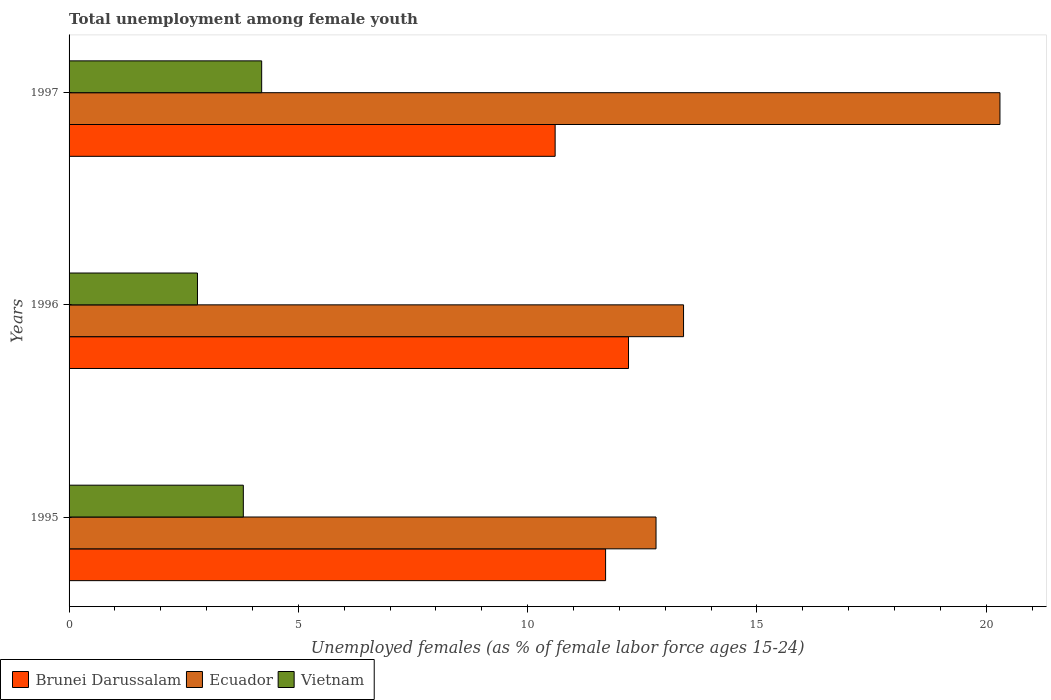How many groups of bars are there?
Your response must be concise. 3. How many bars are there on the 3rd tick from the bottom?
Provide a short and direct response. 3. What is the percentage of unemployed females in in Brunei Darussalam in 1995?
Your answer should be very brief. 11.7. Across all years, what is the maximum percentage of unemployed females in in Vietnam?
Offer a terse response. 4.2. Across all years, what is the minimum percentage of unemployed females in in Brunei Darussalam?
Your answer should be compact. 10.6. In which year was the percentage of unemployed females in in Vietnam maximum?
Offer a very short reply. 1997. In which year was the percentage of unemployed females in in Ecuador minimum?
Provide a short and direct response. 1995. What is the total percentage of unemployed females in in Vietnam in the graph?
Provide a succinct answer. 10.8. What is the difference between the percentage of unemployed females in in Vietnam in 1995 and that in 1997?
Your answer should be compact. -0.4. What is the difference between the percentage of unemployed females in in Brunei Darussalam in 1997 and the percentage of unemployed females in in Ecuador in 1995?
Offer a very short reply. -2.2. What is the average percentage of unemployed females in in Brunei Darussalam per year?
Your answer should be compact. 11.5. In the year 1995, what is the difference between the percentage of unemployed females in in Ecuador and percentage of unemployed females in in Brunei Darussalam?
Make the answer very short. 1.1. In how many years, is the percentage of unemployed females in in Brunei Darussalam greater than 11 %?
Your answer should be compact. 2. What is the ratio of the percentage of unemployed females in in Vietnam in 1995 to that in 1997?
Give a very brief answer. 0.9. Is the percentage of unemployed females in in Vietnam in 1995 less than that in 1996?
Your answer should be very brief. No. What is the difference between the highest and the second highest percentage of unemployed females in in Brunei Darussalam?
Provide a succinct answer. 0.5. What is the difference between the highest and the lowest percentage of unemployed females in in Brunei Darussalam?
Your answer should be very brief. 1.6. In how many years, is the percentage of unemployed females in in Brunei Darussalam greater than the average percentage of unemployed females in in Brunei Darussalam taken over all years?
Your answer should be compact. 2. Is the sum of the percentage of unemployed females in in Brunei Darussalam in 1995 and 1996 greater than the maximum percentage of unemployed females in in Ecuador across all years?
Make the answer very short. Yes. What does the 3rd bar from the top in 1996 represents?
Ensure brevity in your answer.  Brunei Darussalam. What does the 2nd bar from the bottom in 1996 represents?
Provide a short and direct response. Ecuador. How many bars are there?
Your response must be concise. 9. How many years are there in the graph?
Your answer should be very brief. 3. What is the title of the graph?
Your response must be concise. Total unemployment among female youth. Does "Mali" appear as one of the legend labels in the graph?
Your answer should be very brief. No. What is the label or title of the X-axis?
Offer a very short reply. Unemployed females (as % of female labor force ages 15-24). What is the label or title of the Y-axis?
Give a very brief answer. Years. What is the Unemployed females (as % of female labor force ages 15-24) of Brunei Darussalam in 1995?
Offer a very short reply. 11.7. What is the Unemployed females (as % of female labor force ages 15-24) of Ecuador in 1995?
Your answer should be very brief. 12.8. What is the Unemployed females (as % of female labor force ages 15-24) in Vietnam in 1995?
Keep it short and to the point. 3.8. What is the Unemployed females (as % of female labor force ages 15-24) of Brunei Darussalam in 1996?
Your answer should be very brief. 12.2. What is the Unemployed females (as % of female labor force ages 15-24) in Ecuador in 1996?
Provide a succinct answer. 13.4. What is the Unemployed females (as % of female labor force ages 15-24) of Vietnam in 1996?
Make the answer very short. 2.8. What is the Unemployed females (as % of female labor force ages 15-24) of Brunei Darussalam in 1997?
Provide a short and direct response. 10.6. What is the Unemployed females (as % of female labor force ages 15-24) of Ecuador in 1997?
Provide a succinct answer. 20.3. What is the Unemployed females (as % of female labor force ages 15-24) in Vietnam in 1997?
Offer a very short reply. 4.2. Across all years, what is the maximum Unemployed females (as % of female labor force ages 15-24) in Brunei Darussalam?
Your answer should be very brief. 12.2. Across all years, what is the maximum Unemployed females (as % of female labor force ages 15-24) in Ecuador?
Your response must be concise. 20.3. Across all years, what is the maximum Unemployed females (as % of female labor force ages 15-24) of Vietnam?
Your answer should be very brief. 4.2. Across all years, what is the minimum Unemployed females (as % of female labor force ages 15-24) in Brunei Darussalam?
Make the answer very short. 10.6. Across all years, what is the minimum Unemployed females (as % of female labor force ages 15-24) in Ecuador?
Provide a succinct answer. 12.8. Across all years, what is the minimum Unemployed females (as % of female labor force ages 15-24) of Vietnam?
Offer a terse response. 2.8. What is the total Unemployed females (as % of female labor force ages 15-24) of Brunei Darussalam in the graph?
Give a very brief answer. 34.5. What is the total Unemployed females (as % of female labor force ages 15-24) of Ecuador in the graph?
Your answer should be very brief. 46.5. What is the difference between the Unemployed females (as % of female labor force ages 15-24) of Brunei Darussalam in 1995 and that in 1996?
Make the answer very short. -0.5. What is the difference between the Unemployed females (as % of female labor force ages 15-24) in Ecuador in 1995 and that in 1996?
Offer a very short reply. -0.6. What is the difference between the Unemployed females (as % of female labor force ages 15-24) of Vietnam in 1995 and that in 1996?
Give a very brief answer. 1. What is the difference between the Unemployed females (as % of female labor force ages 15-24) of Brunei Darussalam in 1995 and that in 1997?
Provide a short and direct response. 1.1. What is the difference between the Unemployed females (as % of female labor force ages 15-24) in Vietnam in 1995 and that in 1997?
Offer a very short reply. -0.4. What is the difference between the Unemployed females (as % of female labor force ages 15-24) of Brunei Darussalam in 1996 and that in 1997?
Provide a succinct answer. 1.6. What is the difference between the Unemployed females (as % of female labor force ages 15-24) of Ecuador in 1996 and that in 1997?
Offer a very short reply. -6.9. What is the difference between the Unemployed females (as % of female labor force ages 15-24) in Brunei Darussalam in 1995 and the Unemployed females (as % of female labor force ages 15-24) in Vietnam in 1996?
Provide a succinct answer. 8.9. What is the difference between the Unemployed females (as % of female labor force ages 15-24) in Ecuador in 1995 and the Unemployed females (as % of female labor force ages 15-24) in Vietnam in 1996?
Give a very brief answer. 10. What is the difference between the Unemployed females (as % of female labor force ages 15-24) of Brunei Darussalam in 1995 and the Unemployed females (as % of female labor force ages 15-24) of Ecuador in 1997?
Your answer should be compact. -8.6. What is the average Unemployed females (as % of female labor force ages 15-24) of Ecuador per year?
Your answer should be very brief. 15.5. What is the average Unemployed females (as % of female labor force ages 15-24) of Vietnam per year?
Provide a succinct answer. 3.6. In the year 1995, what is the difference between the Unemployed females (as % of female labor force ages 15-24) in Ecuador and Unemployed females (as % of female labor force ages 15-24) in Vietnam?
Your answer should be compact. 9. In the year 1996, what is the difference between the Unemployed females (as % of female labor force ages 15-24) of Brunei Darussalam and Unemployed females (as % of female labor force ages 15-24) of Ecuador?
Provide a succinct answer. -1.2. In the year 1996, what is the difference between the Unemployed females (as % of female labor force ages 15-24) of Brunei Darussalam and Unemployed females (as % of female labor force ages 15-24) of Vietnam?
Your answer should be compact. 9.4. In the year 1996, what is the difference between the Unemployed females (as % of female labor force ages 15-24) in Ecuador and Unemployed females (as % of female labor force ages 15-24) in Vietnam?
Make the answer very short. 10.6. In the year 1997, what is the difference between the Unemployed females (as % of female labor force ages 15-24) of Brunei Darussalam and Unemployed females (as % of female labor force ages 15-24) of Ecuador?
Provide a short and direct response. -9.7. In the year 1997, what is the difference between the Unemployed females (as % of female labor force ages 15-24) of Ecuador and Unemployed females (as % of female labor force ages 15-24) of Vietnam?
Your answer should be very brief. 16.1. What is the ratio of the Unemployed females (as % of female labor force ages 15-24) in Ecuador in 1995 to that in 1996?
Offer a very short reply. 0.96. What is the ratio of the Unemployed females (as % of female labor force ages 15-24) of Vietnam in 1995 to that in 1996?
Ensure brevity in your answer.  1.36. What is the ratio of the Unemployed females (as % of female labor force ages 15-24) in Brunei Darussalam in 1995 to that in 1997?
Offer a terse response. 1.1. What is the ratio of the Unemployed females (as % of female labor force ages 15-24) in Ecuador in 1995 to that in 1997?
Keep it short and to the point. 0.63. What is the ratio of the Unemployed females (as % of female labor force ages 15-24) of Vietnam in 1995 to that in 1997?
Keep it short and to the point. 0.9. What is the ratio of the Unemployed females (as % of female labor force ages 15-24) in Brunei Darussalam in 1996 to that in 1997?
Your answer should be very brief. 1.15. What is the ratio of the Unemployed females (as % of female labor force ages 15-24) in Ecuador in 1996 to that in 1997?
Your answer should be compact. 0.66. What is the difference between the highest and the second highest Unemployed females (as % of female labor force ages 15-24) of Ecuador?
Keep it short and to the point. 6.9. What is the difference between the highest and the second highest Unemployed females (as % of female labor force ages 15-24) in Vietnam?
Offer a very short reply. 0.4. What is the difference between the highest and the lowest Unemployed females (as % of female labor force ages 15-24) in Brunei Darussalam?
Your answer should be very brief. 1.6. What is the difference between the highest and the lowest Unemployed females (as % of female labor force ages 15-24) of Vietnam?
Offer a very short reply. 1.4. 